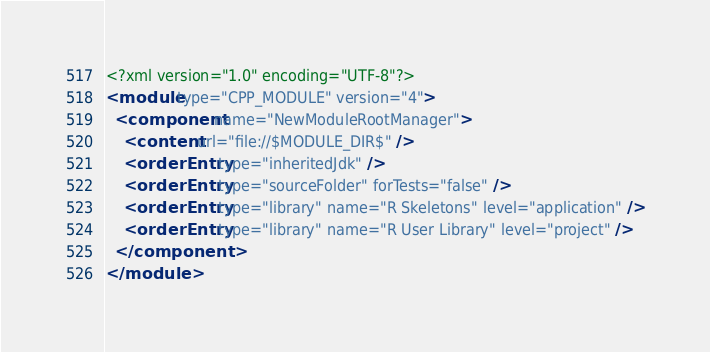Convert code to text. <code><loc_0><loc_0><loc_500><loc_500><_XML_><?xml version="1.0" encoding="UTF-8"?>
<module type="CPP_MODULE" version="4">
  <component name="NewModuleRootManager">
    <content url="file://$MODULE_DIR$" />
    <orderEntry type="inheritedJdk" />
    <orderEntry type="sourceFolder" forTests="false" />
    <orderEntry type="library" name="R Skeletons" level="application" />
    <orderEntry type="library" name="R User Library" level="project" />
  </component>
</module></code> 